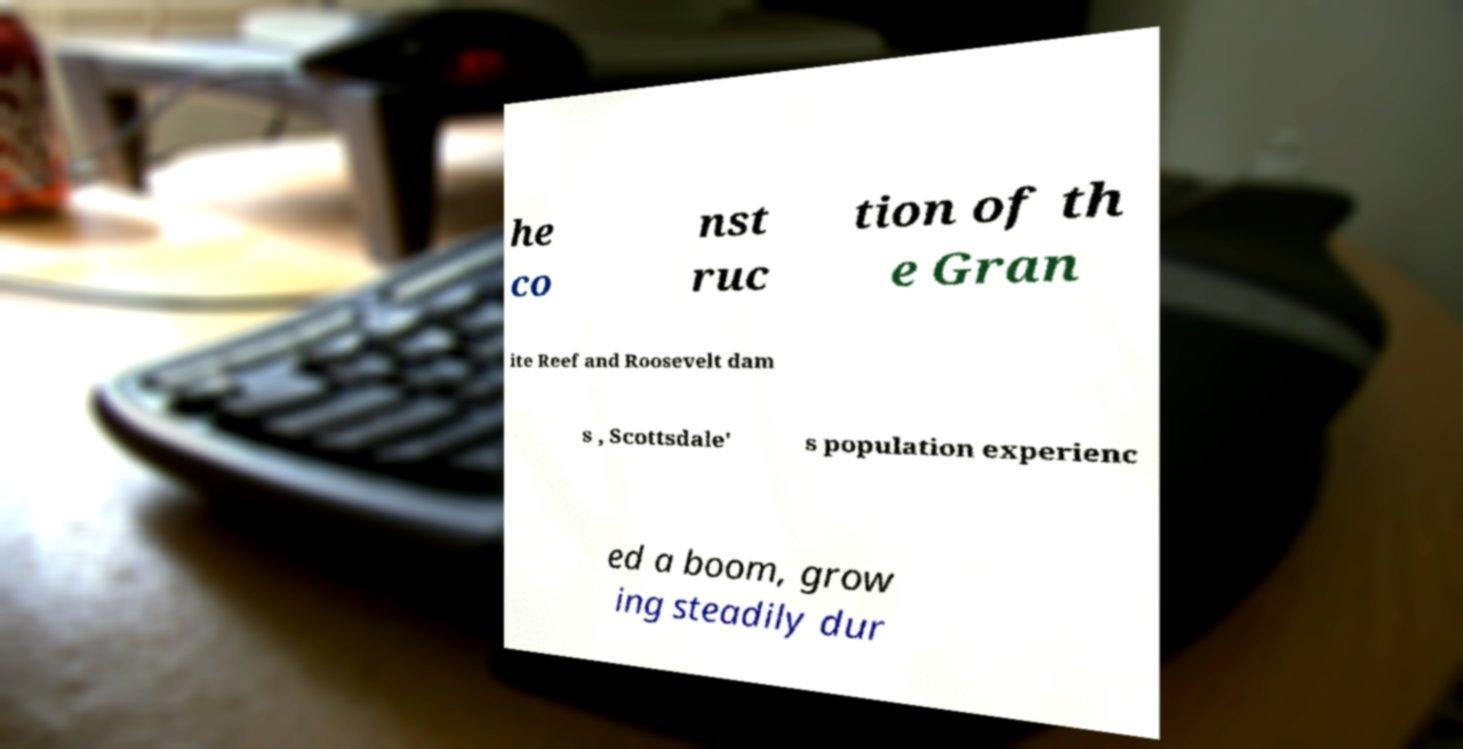What messages or text are displayed in this image? I need them in a readable, typed format. he co nst ruc tion of th e Gran ite Reef and Roosevelt dam s , Scottsdale' s population experienc ed a boom, grow ing steadily dur 